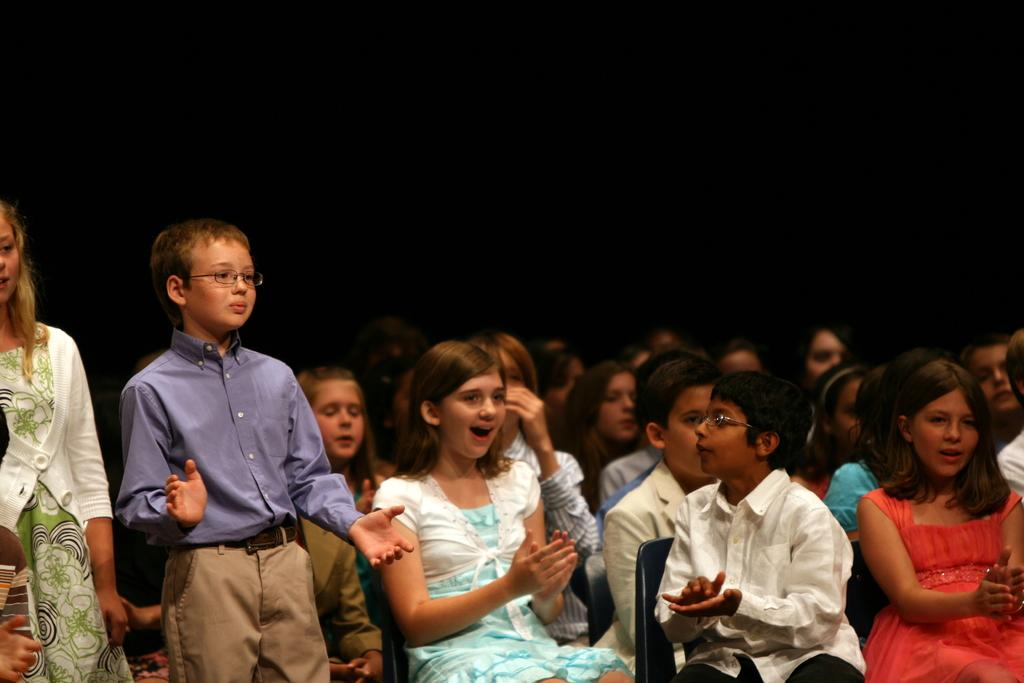What are the people in the image doing? There are people sitting on chairs and some people are standing in the image. Can you describe the background of the image? The background of the image is in black color. How many legs does the vacation have in the image? There is no vacation present in the image, so it cannot be determined how many legs it might have. 